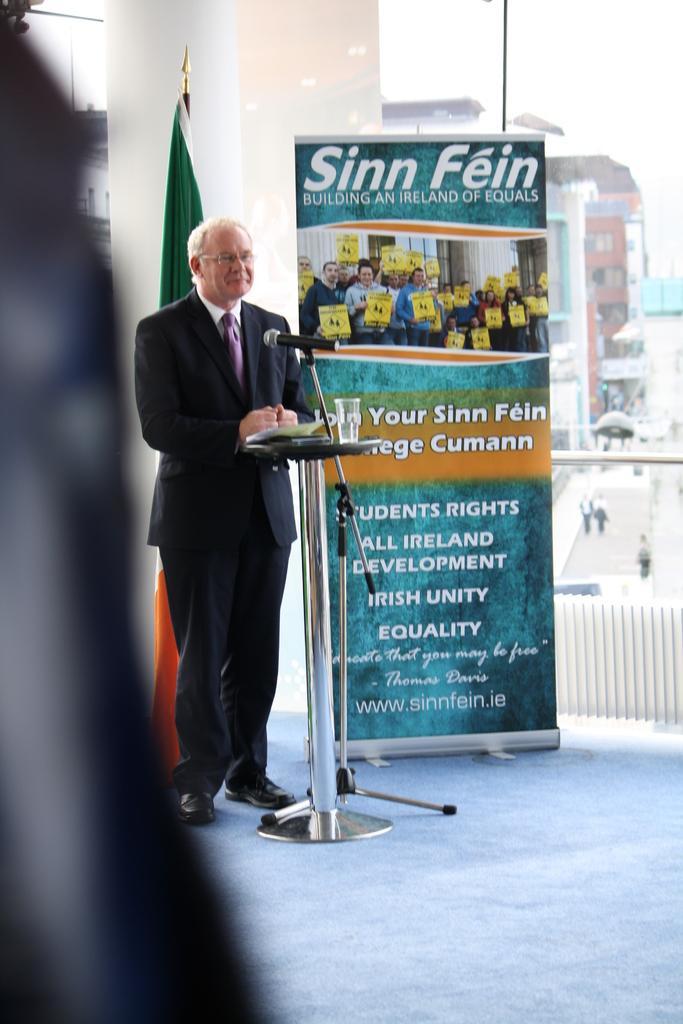How would you summarize this image in a sentence or two? In this image we can see a person standing in front of the mic, there is a flag and a poster with some text and in the background we can see some buildings. 